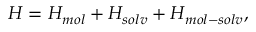<formula> <loc_0><loc_0><loc_500><loc_500>\begin{array} { r } { H = H _ { m o l } + H _ { s o l v } + H _ { m o l - s o l v } , } \end{array}</formula> 